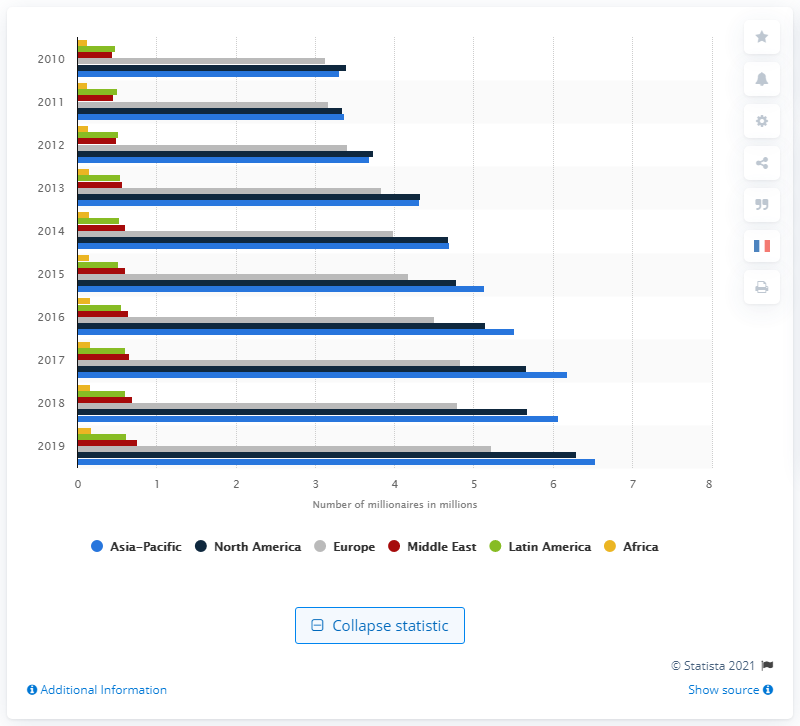What was the number of millionaires in the Asia Pacific region in 2019?
 6.53 